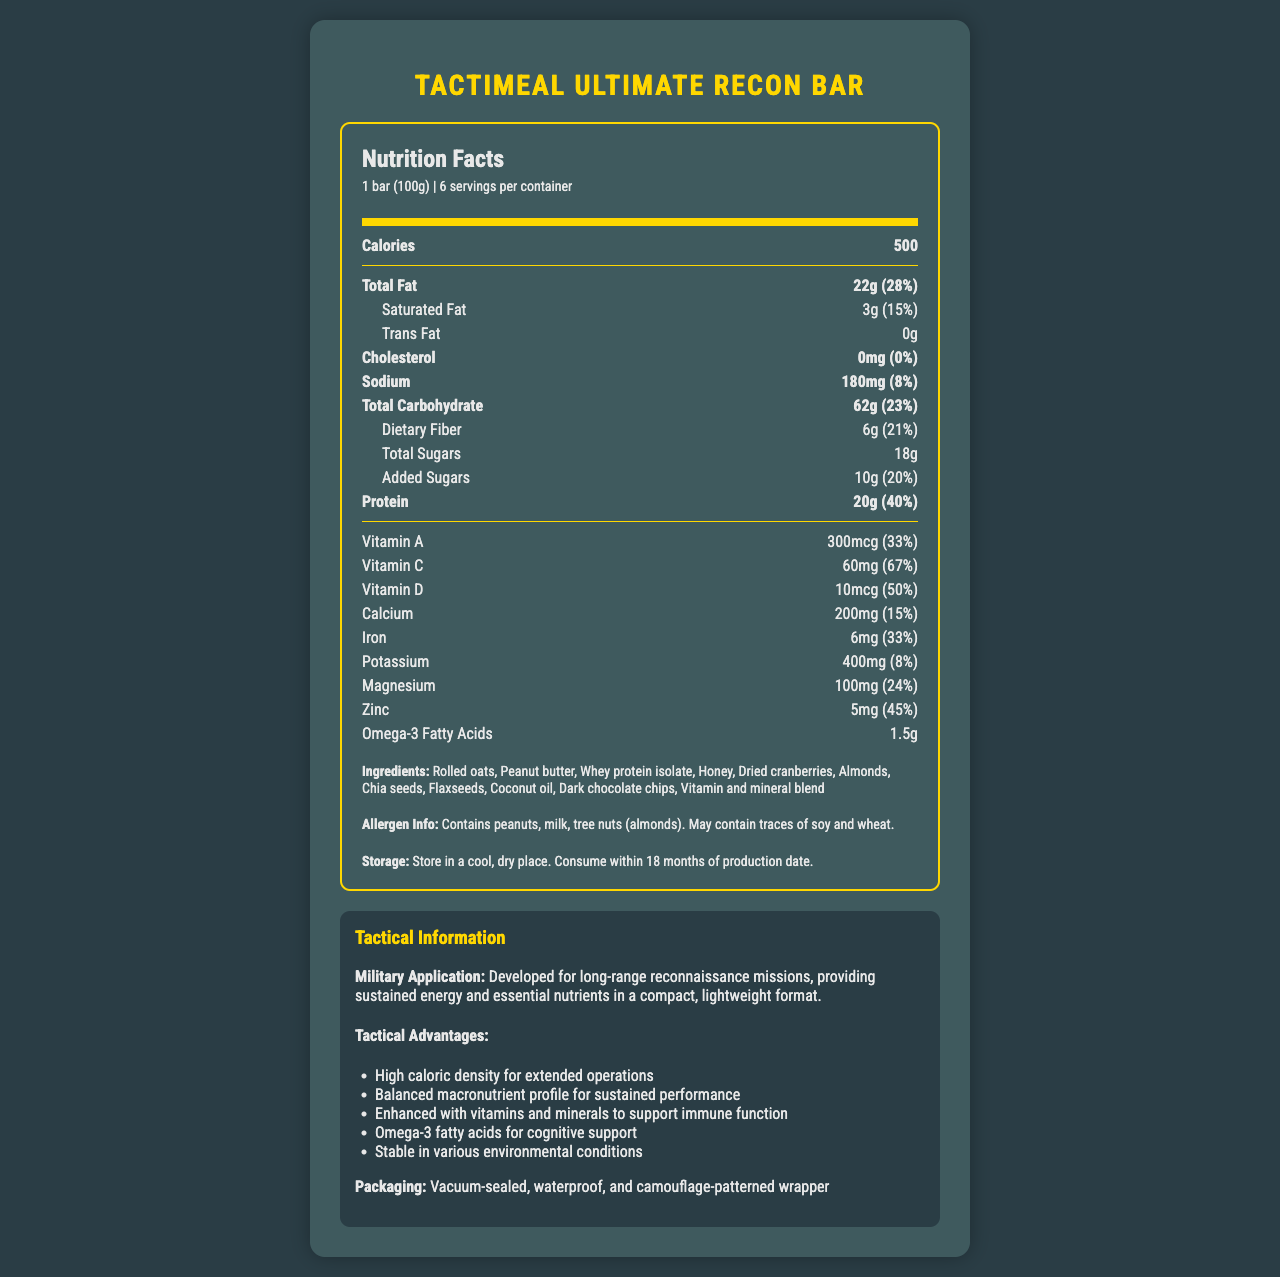what is the serving size of the TactiMeal Ultimate Recon Bar? The serving size is stated directly under the product name in the document.
Answer: 1 bar (100g) How many calories does one bar contain? The calorie content for one serving size (1 bar) is explicitly mentioned in the document.
Answer: 500 What is the total carbohydrate content per serving? The total carbohydrate amount is specified under the macronutrient breakdown section.
Answer: 62g How much dietary fiber is in one serving? The dietary fiber content is listed under the total carbohydrate subsection.
Answer: 6g Which of the following vitamins has the highest daily value percentage per serving? A. Vitamin A B. Vitamin C C. Vitamin D Vitamin C has a daily value percentage of 67%, which is higher than that of Vitamin A (33%) and Vitamin D (50%).
Answer: B Is the TactiMeal Ultimate Recon Bar suitable for someone with a peanut allergy? The allergen info clearly states that it contains peanuts.
Answer: No How many grams of protein does one bar provide? The protein content per serving size is identified in the nutrition facts.
Answer: 20g What is the daily value percentage of total fat in one serving? The daily value percentage for total fat is mentioned next to its respective amount.
Answer: 28% What is the total sugar content in one serving, including added sugars? The document lists total sugars as 18g and explicitly states added sugars as 10g.
Answer: 18g total sugars, 10g added sugars Which nutrient provides cognitive support, according to the tactical advantages? The document mentions that Omega-3 fatty acids support cognitive function.
Answer: Omega-3 fatty acids What is the storage instruction for the TactiMeal Ultimate Recon Bar? The storage instructions provide specific details on how to store the product.
Answer: Store in a cool, dry place. Consume within 18 months of production date. Can the exact production date of the TactiMeal Ultimate Recon Bar be determined from the document? The document does not provide the exact production date, only that it should be consumed within 18 months from that date.
Answer: Not enough information Describe the main tactical advantages of the TactiMeal Ultimate Recon Bar. These points summarize the tactical advantages listed under the tactical info section of the document.
Answer: High caloric density for extended operations; Balanced macronutrient profile for sustained performance; Enhanced with vitamins and minerals to support immune function; Omega-3 fatty acids for cognitive support; Stable in various environmental conditions What is the total amount of sodium per container? There are 180mg of sodium per serving, and with 6 servings per container, the total is 180mg * 6 = 1080mg.
Answer: 1080mg To achieve 100% of your daily protein value, approximately how many bars would you need to consume? One bar provides 40% of the daily value for protein, so to reach 100%, you would need about 100% / 40% = 2.5 bars.
Answer: 2.5 bars Which of the following is NOT an ingredient in the TactiMeal Ultimate Recon Bar? A. Dried apples B. Almonds C. Honey D. Dark chocolate chips Dried apples are not listed in the ingredients, while almonds, honey, and dark chocolate chips are included.
Answer: A Is the packaging of the TactiMeal Ultimate Recon Bar specialized for military use? The packaging is described as vacuum-sealed, waterproof, and camouflage-patterned, which is suitable for military applications.
Answer: Yes 